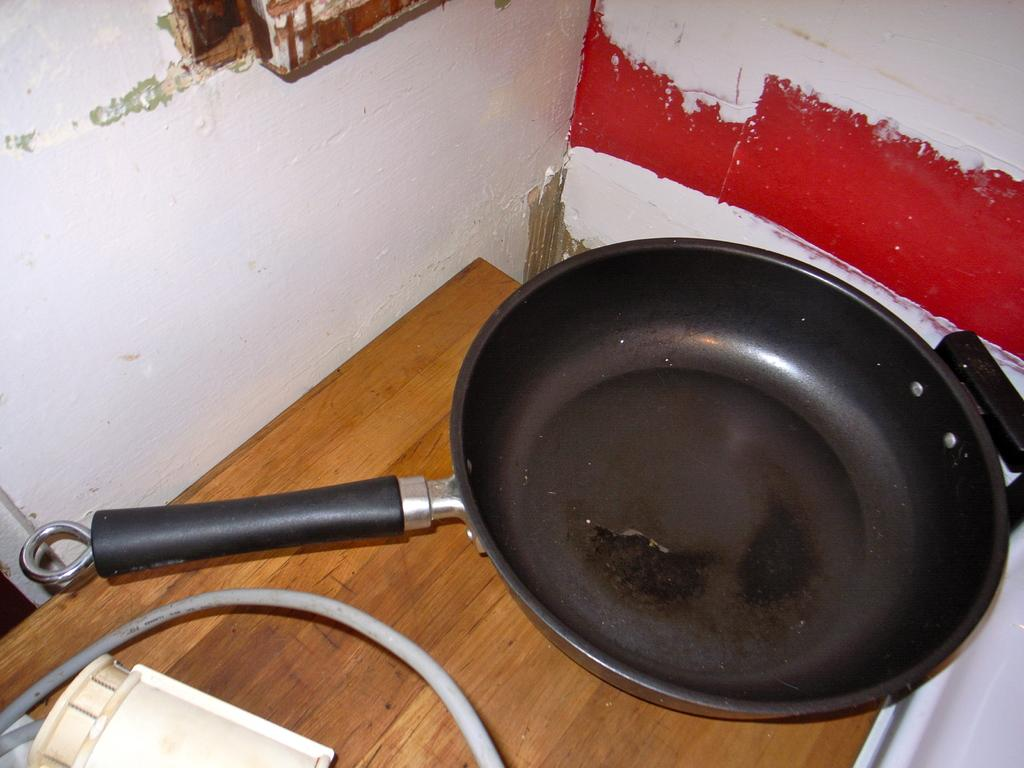What is the main object on the table in the image? There is a pan in the image. What else can be seen on the table in the image? There is a wire in the image. Can you describe the location of the pan and the wire in the image? Both the pan and the wire are on a table. What date is circled on the calendar in the image? There is no calendar present in the image. Who is the owner of the sheet visible in the image? There is no sheet visible in the image. 